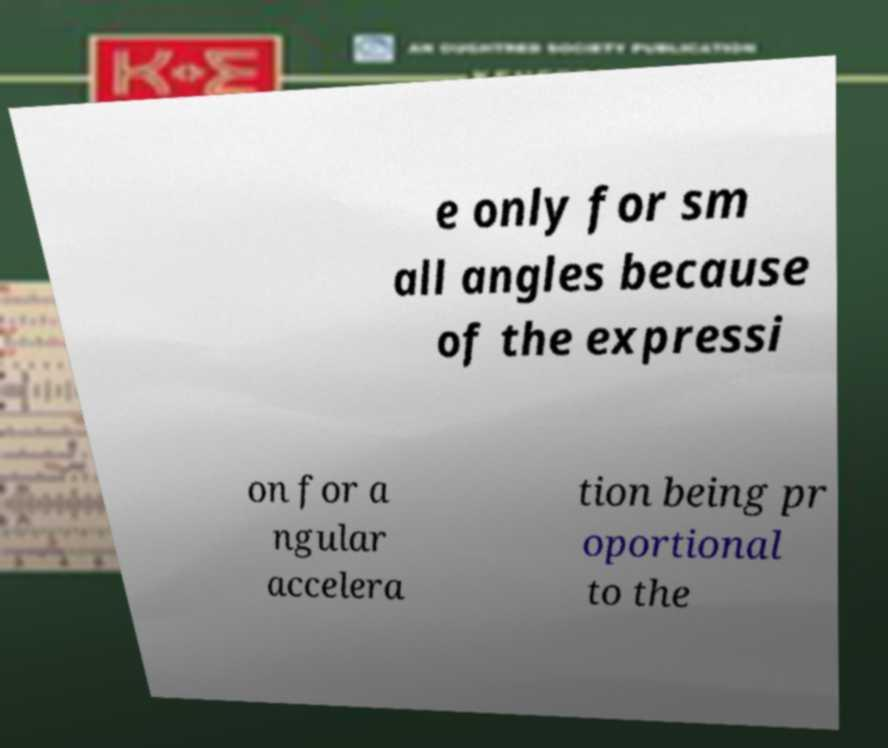I need the written content from this picture converted into text. Can you do that? e only for sm all angles because of the expressi on for a ngular accelera tion being pr oportional to the 